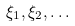<formula> <loc_0><loc_0><loc_500><loc_500>\xi _ { 1 } , \xi _ { 2 } , \dots</formula> 